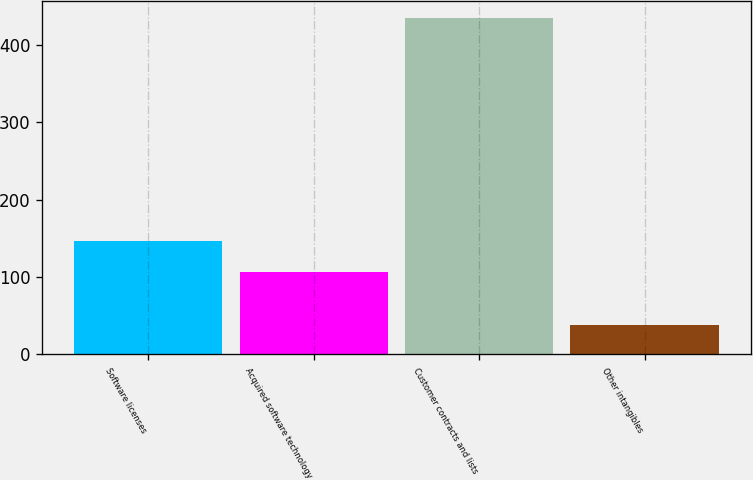Convert chart to OTSL. <chart><loc_0><loc_0><loc_500><loc_500><bar_chart><fcel>Software licenses<fcel>Acquired software technology<fcel>Customer contracts and lists<fcel>Other intangibles<nl><fcel>146.62<fcel>106.9<fcel>435.3<fcel>38.1<nl></chart> 